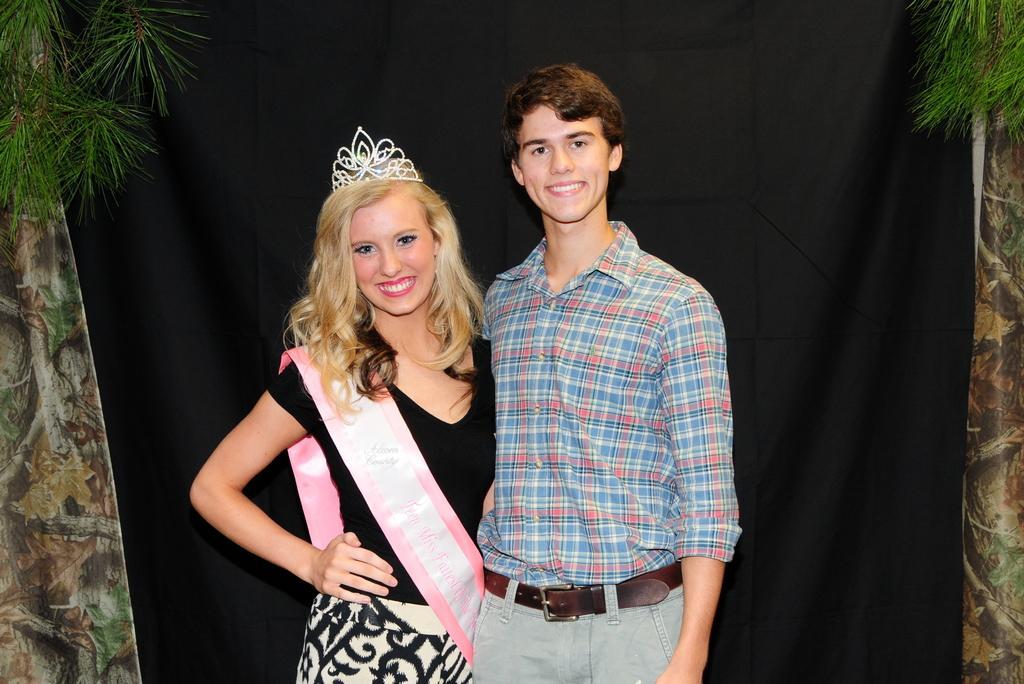Describe this image in one or two sentences. In this image there are two persons standing in the middle of this image and the person standing on the left side of this image is wearing a crown. There is a black color cloth in the background. There is an another cloth on the left side of this image and on the right side of this image as well. 